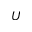Convert formula to latex. <formula><loc_0><loc_0><loc_500><loc_500>U</formula> 